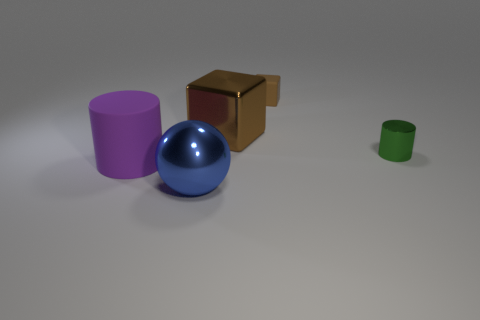Add 2 brown rubber blocks. How many objects exist? 7 Subtract all cubes. How many objects are left? 3 Add 5 yellow metallic cubes. How many yellow metallic cubes exist? 5 Subtract 0 gray cubes. How many objects are left? 5 Subtract all tiny metal cylinders. Subtract all large brown shiny objects. How many objects are left? 3 Add 3 tiny cylinders. How many tiny cylinders are left? 4 